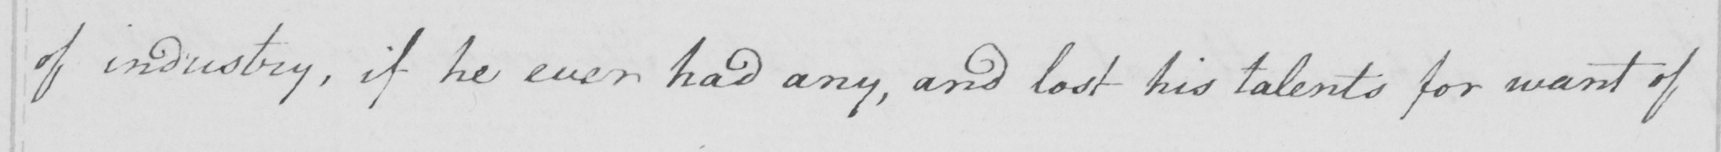Can you read and transcribe this handwriting? of industry , if he ever had any , and lost his talents for want of 